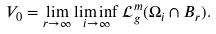Convert formula to latex. <formula><loc_0><loc_0><loc_500><loc_500>V _ { 0 } = \lim _ { r \to \infty } \liminf _ { i \to \infty } \mathcal { L } ^ { m } _ { g } ( \Omega _ { i } \cap B _ { r } ) .</formula> 